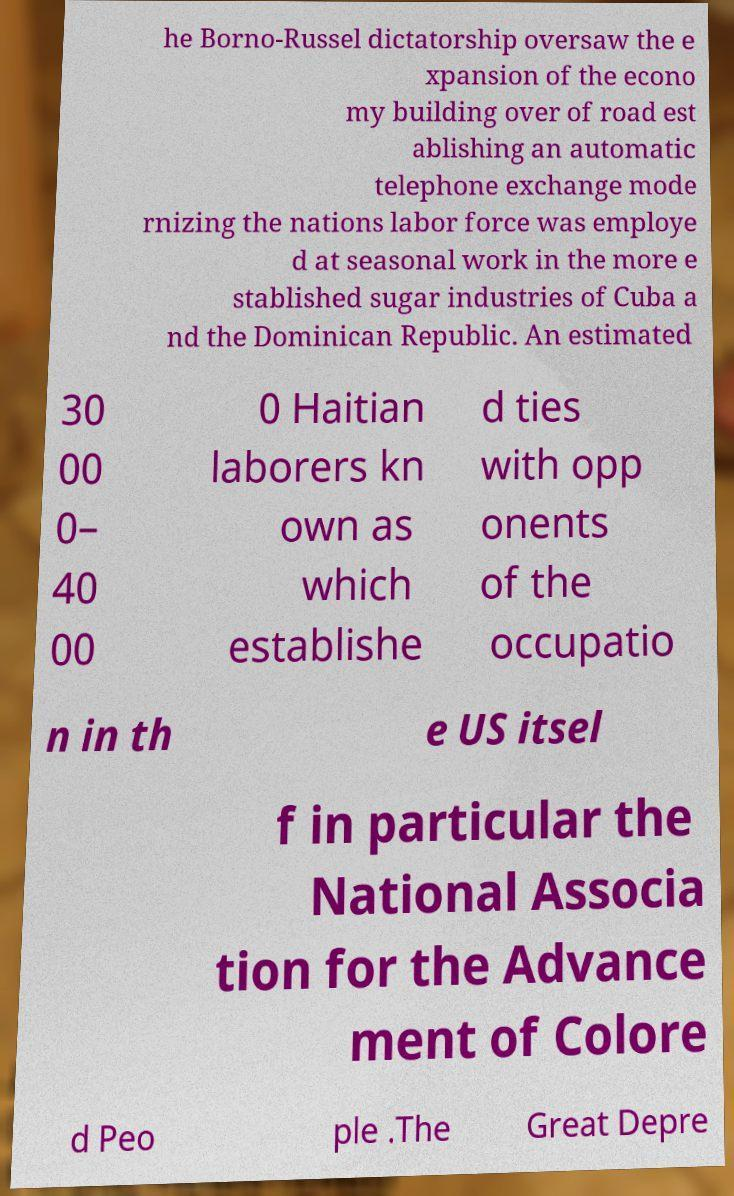Please identify and transcribe the text found in this image. he Borno-Russel dictatorship oversaw the e xpansion of the econo my building over of road est ablishing an automatic telephone exchange mode rnizing the nations labor force was employe d at seasonal work in the more e stablished sugar industries of Cuba a nd the Dominican Republic. An estimated 30 00 0– 40 00 0 Haitian laborers kn own as which establishe d ties with opp onents of the occupatio n in th e US itsel f in particular the National Associa tion for the Advance ment of Colore d Peo ple .The Great Depre 